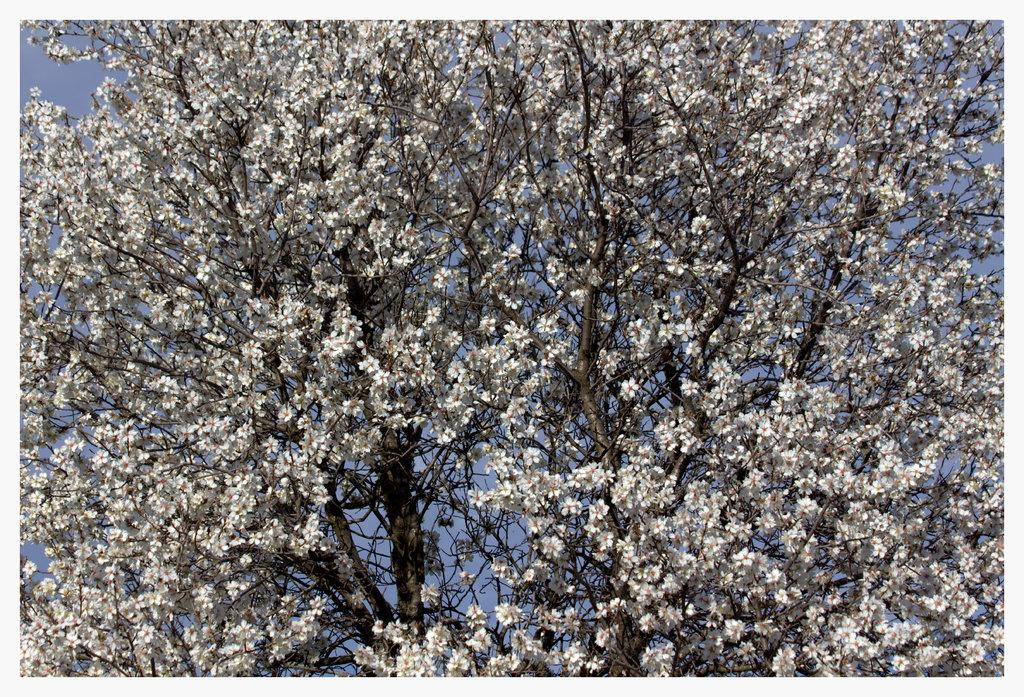What type of vegetation can be seen in the image? There are trees in the image. What color are the flowers in the image? The flowers in the image are white. What part of the natural environment is visible in the image? The sky is visible in the image. What type of stone can be seen on the shoes in the image? There are no shoes or stones present in the image; it features trees and white flowers. 